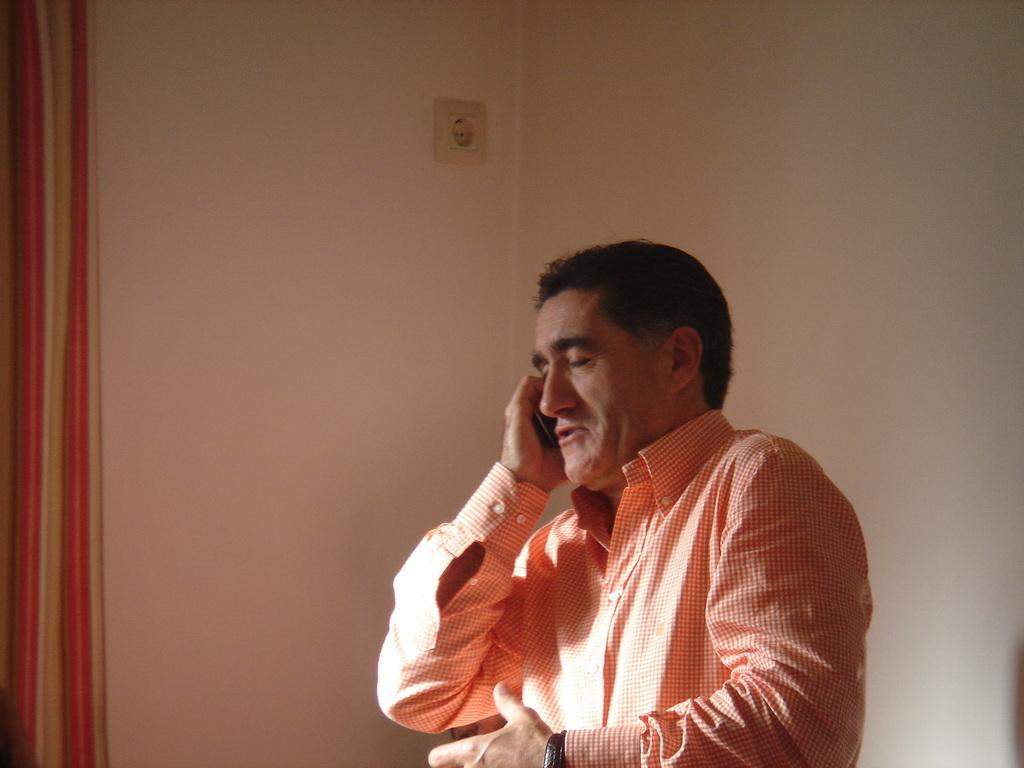What is the main subject of the image? There is a man standing in the center of the image. What is the man holding in the image? The man is holding a mobile. What is the man doing in the image? The man is talking. What can be seen in the background of the image? There is a wall, a board, and a curtain in the background of the image. Is there any dirt visible on the man's shoes in the image? There is no information about the man's shoes or any dirt on them in the provided facts. 